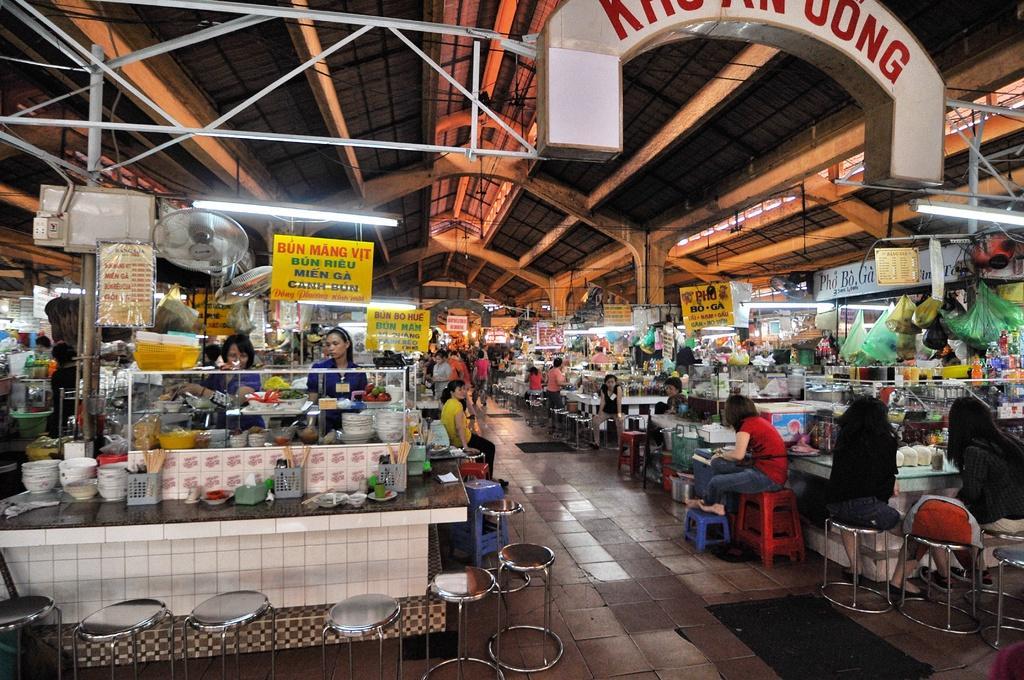Please provide a concise description of this image. Here we can see food courts and chairs on the floor. We can see hoardings,plates,bowls,food items on both the left and right side. In the background there are few people standing and few are sitting on the chairs. We can also see table fan,lights on the roof top,poles,electric wires and some other items. 